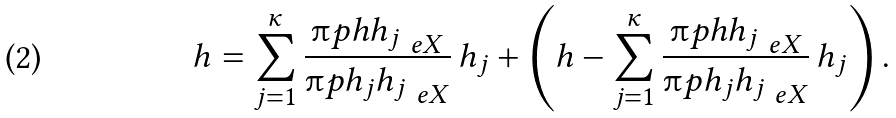<formula> <loc_0><loc_0><loc_500><loc_500>h = \sum _ { j = 1 } ^ { \kappa } \frac { { \i p { h } { h _ { j } } } _ { \ e X } } { { \i p { h _ { j } } { h _ { j } } } _ { \ e X } } \, h _ { j } + \left ( h - \sum _ { j = 1 } ^ { \kappa } \frac { { \i p { h } { h _ { j } } } _ { \ e X } } { { \i p { h _ { j } } { h _ { j } } } _ { \ e X } } \, h _ { j } \right ) .</formula> 